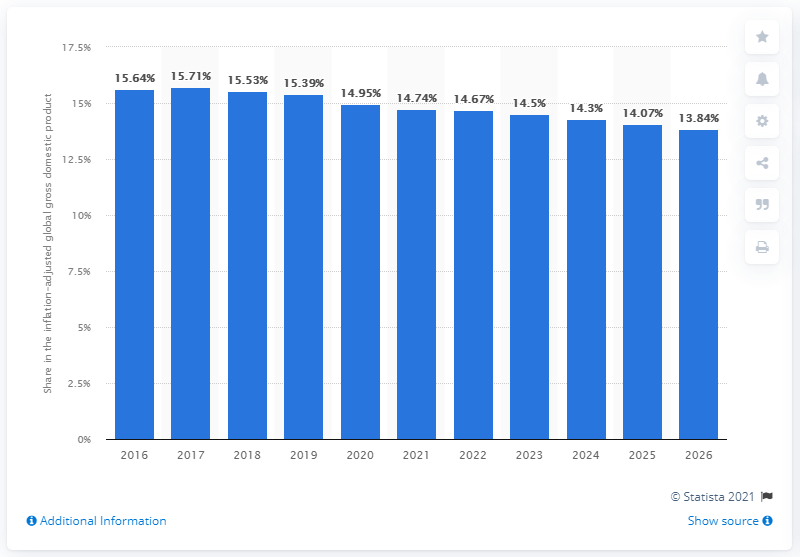Draw attention to some important aspects in this diagram. In 2019, the European Union's share of the global gross domestic product based on purchasing-power-parity was 15.39%. 